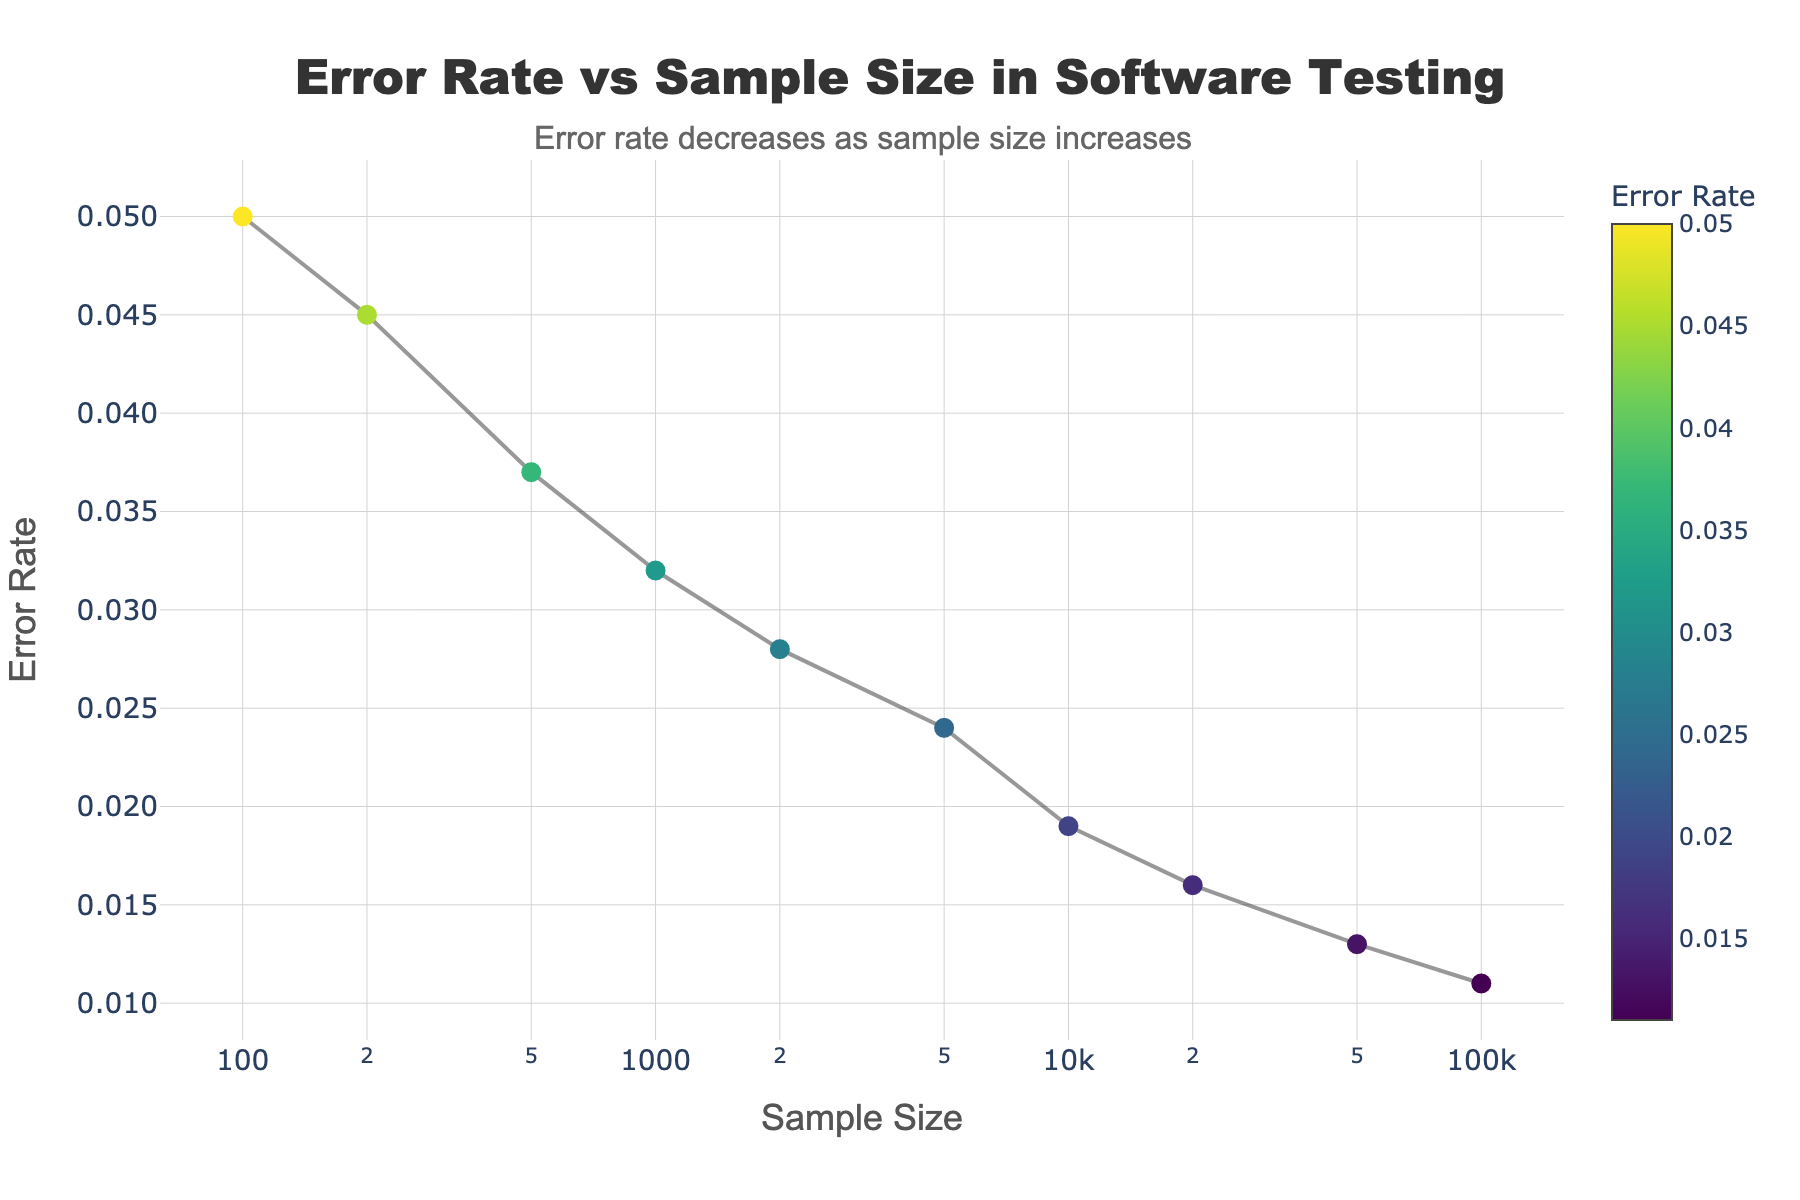What's the title of the plot? The title can be found at the top center of the figure. It states the main subject of the plot.
Answer: Error Rate vs Sample Size in Software Testing How does the error rate change as the sample size increases? Observing the trend in the plot, we see that as the sample size on the x-axis increases, the error rate on the y-axis decreases.
Answer: Error rate decreases What is the sample size corresponding to an error rate of 0.013? Find the data point where the y-value (error rate) is 0.013 and then look at the corresponding x-value (sample size).
Answer: 50000 Which sample size has the smallest error rate? Look for the data point that has the smallest y-value (error rate), then read the corresponding x-value (sample size).
Answer: 100000 How many data points are there in the plot? Each data point is represented by a marker on the plot. Count the total number of markers.
Answer: 10 At what sample size does the error rate first go below 0.02? Identify the point where the y-value (error rate) first drops below 0.02 by looking from left to right, then note the corresponding x-value (sample size).
Answer: 10000 Compare the error rates for sample sizes of 200 and 10000. Which has a higher error rate? Locate the error rates for sample sizes 200 and 10000. The value at 200 is 0.045, and the value at 10000 is 0.019. Determine which one is higher.
Answer: 200 What is the visual cue used to indicate the error rate on the markers? Look for any color scale or bar that shows how the colors of the markers correspond to the error rates.
Answer: Color scale Explain the trend displayed in the plot. Analyze the overall direction in which the error rate moves as the sample size increases. The error rate steadily decreases as sample size grows.
Answer: The error rate decreases as sample size increases What's the error rate for a sample size of 1000, and how much does it decrease when sample size is doubled to 2000? Find the error rate for 1000 (0.032) and 2000 (0.028). Calculate the decrease: 0.032 - 0.028 = 0.004.
Answer: 0.004 